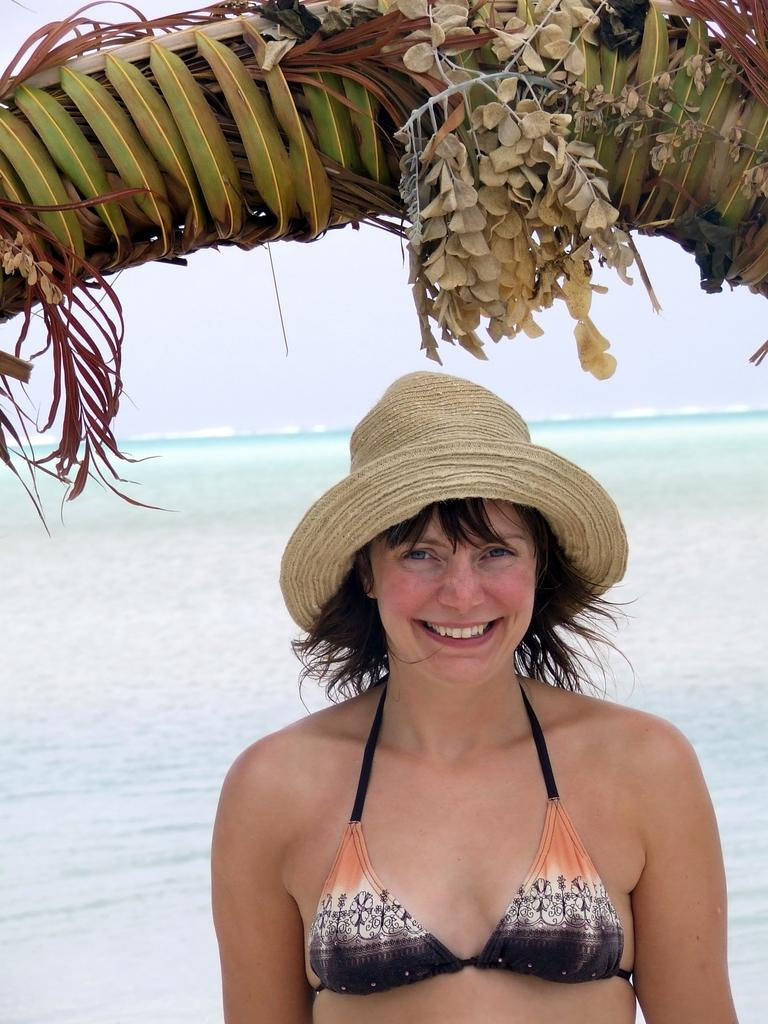Who is present in the image? There is a woman in the image. What is the setting of the image? The woman is standing in front of a beach. What is the woman's facial expression? The woman is smiling. What is the woman wearing on her head? The woman is wearing a hat. What can be seen above the woman's head? There is a tree branch above the woman's head. What type of pet is the woman holding in the image? There is no pet visible in the image. How many ducks can be seen swimming in the water near the woman? There are no ducks visible in the image; the woman is standing in front of a beach, but no animals are present. 